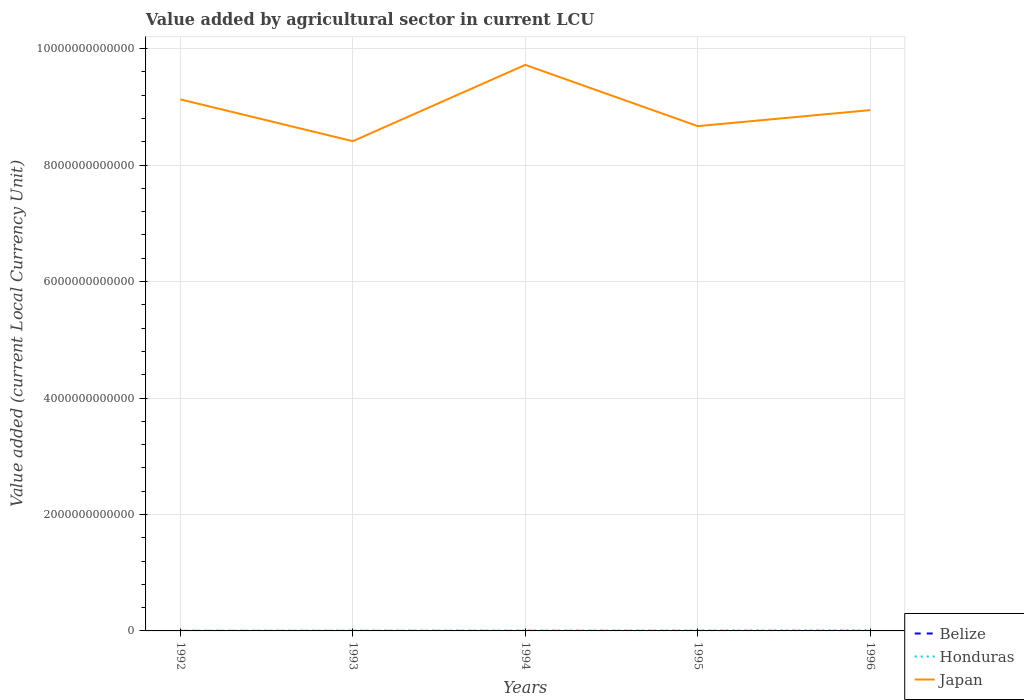Does the line corresponding to Honduras intersect with the line corresponding to Japan?
Make the answer very short. No. Is the number of lines equal to the number of legend labels?
Offer a very short reply. Yes. Across all years, what is the maximum value added by agricultural sector in Japan?
Your answer should be compact. 8.41e+12. In which year was the value added by agricultural sector in Japan maximum?
Offer a very short reply. 1993. What is the total value added by agricultural sector in Honduras in the graph?
Make the answer very short. -5.17e+09. What is the difference between the highest and the second highest value added by agricultural sector in Belize?
Ensure brevity in your answer.  3.73e+07. What is the difference between the highest and the lowest value added by agricultural sector in Belize?
Make the answer very short. 2. Is the value added by agricultural sector in Honduras strictly greater than the value added by agricultural sector in Belize over the years?
Your response must be concise. No. How many lines are there?
Give a very brief answer. 3. How many years are there in the graph?
Provide a short and direct response. 5. What is the difference between two consecutive major ticks on the Y-axis?
Your response must be concise. 2.00e+12. Where does the legend appear in the graph?
Keep it short and to the point. Bottom right. How are the legend labels stacked?
Your answer should be compact. Vertical. What is the title of the graph?
Keep it short and to the point. Value added by agricultural sector in current LCU. Does "Solomon Islands" appear as one of the legend labels in the graph?
Offer a terse response. No. What is the label or title of the X-axis?
Make the answer very short. Years. What is the label or title of the Y-axis?
Your response must be concise. Value added (current Local Currency Unit). What is the Value added (current Local Currency Unit) of Belize in 1992?
Your answer should be compact. 1.65e+08. What is the Value added (current Local Currency Unit) in Honduras in 1992?
Offer a terse response. 3.29e+09. What is the Value added (current Local Currency Unit) in Japan in 1992?
Your answer should be compact. 9.13e+12. What is the Value added (current Local Currency Unit) of Belize in 1993?
Make the answer very short. 1.69e+08. What is the Value added (current Local Currency Unit) in Honduras in 1993?
Your answer should be very brief. 4.01e+09. What is the Value added (current Local Currency Unit) in Japan in 1993?
Ensure brevity in your answer.  8.41e+12. What is the Value added (current Local Currency Unit) in Belize in 1994?
Offer a very short reply. 1.75e+08. What is the Value added (current Local Currency Unit) in Honduras in 1994?
Your answer should be compact. 6.03e+09. What is the Value added (current Local Currency Unit) in Japan in 1994?
Provide a succinct answer. 9.72e+12. What is the Value added (current Local Currency Unit) in Belize in 1995?
Provide a short and direct response. 1.98e+08. What is the Value added (current Local Currency Unit) in Honduras in 1995?
Give a very brief answer. 7.03e+09. What is the Value added (current Local Currency Unit) of Japan in 1995?
Your answer should be compact. 8.67e+12. What is the Value added (current Local Currency Unit) in Belize in 1996?
Give a very brief answer. 2.03e+08. What is the Value added (current Local Currency Unit) in Honduras in 1996?
Offer a terse response. 9.19e+09. What is the Value added (current Local Currency Unit) in Japan in 1996?
Your answer should be very brief. 8.94e+12. Across all years, what is the maximum Value added (current Local Currency Unit) in Belize?
Keep it short and to the point. 2.03e+08. Across all years, what is the maximum Value added (current Local Currency Unit) in Honduras?
Ensure brevity in your answer.  9.19e+09. Across all years, what is the maximum Value added (current Local Currency Unit) in Japan?
Give a very brief answer. 9.72e+12. Across all years, what is the minimum Value added (current Local Currency Unit) of Belize?
Offer a very short reply. 1.65e+08. Across all years, what is the minimum Value added (current Local Currency Unit) in Honduras?
Make the answer very short. 3.29e+09. Across all years, what is the minimum Value added (current Local Currency Unit) of Japan?
Make the answer very short. 8.41e+12. What is the total Value added (current Local Currency Unit) of Belize in the graph?
Keep it short and to the point. 9.10e+08. What is the total Value added (current Local Currency Unit) in Honduras in the graph?
Make the answer very short. 2.95e+1. What is the total Value added (current Local Currency Unit) in Japan in the graph?
Offer a very short reply. 4.49e+13. What is the difference between the Value added (current Local Currency Unit) of Belize in 1992 and that in 1993?
Make the answer very short. -3.79e+06. What is the difference between the Value added (current Local Currency Unit) of Honduras in 1992 and that in 1993?
Your answer should be compact. -7.28e+08. What is the difference between the Value added (current Local Currency Unit) of Japan in 1992 and that in 1993?
Make the answer very short. 7.18e+11. What is the difference between the Value added (current Local Currency Unit) of Belize in 1992 and that in 1994?
Provide a succinct answer. -9.67e+06. What is the difference between the Value added (current Local Currency Unit) in Honduras in 1992 and that in 1994?
Your response must be concise. -2.74e+09. What is the difference between the Value added (current Local Currency Unit) in Japan in 1992 and that in 1994?
Give a very brief answer. -5.93e+11. What is the difference between the Value added (current Local Currency Unit) of Belize in 1992 and that in 1995?
Offer a very short reply. -3.22e+07. What is the difference between the Value added (current Local Currency Unit) of Honduras in 1992 and that in 1995?
Your answer should be very brief. -3.74e+09. What is the difference between the Value added (current Local Currency Unit) of Japan in 1992 and that in 1995?
Provide a succinct answer. 4.59e+11. What is the difference between the Value added (current Local Currency Unit) of Belize in 1992 and that in 1996?
Make the answer very short. -3.73e+07. What is the difference between the Value added (current Local Currency Unit) in Honduras in 1992 and that in 1996?
Provide a succinct answer. -5.90e+09. What is the difference between the Value added (current Local Currency Unit) of Japan in 1992 and that in 1996?
Offer a very short reply. 1.84e+11. What is the difference between the Value added (current Local Currency Unit) of Belize in 1993 and that in 1994?
Your response must be concise. -5.88e+06. What is the difference between the Value added (current Local Currency Unit) of Honduras in 1993 and that in 1994?
Keep it short and to the point. -2.02e+09. What is the difference between the Value added (current Local Currency Unit) of Japan in 1993 and that in 1994?
Your response must be concise. -1.31e+12. What is the difference between the Value added (current Local Currency Unit) of Belize in 1993 and that in 1995?
Make the answer very short. -2.84e+07. What is the difference between the Value added (current Local Currency Unit) in Honduras in 1993 and that in 1995?
Provide a succinct answer. -3.01e+09. What is the difference between the Value added (current Local Currency Unit) of Japan in 1993 and that in 1995?
Provide a succinct answer. -2.59e+11. What is the difference between the Value added (current Local Currency Unit) of Belize in 1993 and that in 1996?
Provide a succinct answer. -3.36e+07. What is the difference between the Value added (current Local Currency Unit) in Honduras in 1993 and that in 1996?
Your answer should be compact. -5.17e+09. What is the difference between the Value added (current Local Currency Unit) in Japan in 1993 and that in 1996?
Your answer should be very brief. -5.33e+11. What is the difference between the Value added (current Local Currency Unit) in Belize in 1994 and that in 1995?
Your answer should be very brief. -2.25e+07. What is the difference between the Value added (current Local Currency Unit) of Honduras in 1994 and that in 1995?
Keep it short and to the point. -9.96e+08. What is the difference between the Value added (current Local Currency Unit) in Japan in 1994 and that in 1995?
Ensure brevity in your answer.  1.05e+12. What is the difference between the Value added (current Local Currency Unit) in Belize in 1994 and that in 1996?
Offer a terse response. -2.77e+07. What is the difference between the Value added (current Local Currency Unit) of Honduras in 1994 and that in 1996?
Make the answer very short. -3.16e+09. What is the difference between the Value added (current Local Currency Unit) of Japan in 1994 and that in 1996?
Give a very brief answer. 7.77e+11. What is the difference between the Value added (current Local Currency Unit) in Belize in 1995 and that in 1996?
Give a very brief answer. -5.16e+06. What is the difference between the Value added (current Local Currency Unit) of Honduras in 1995 and that in 1996?
Your answer should be compact. -2.16e+09. What is the difference between the Value added (current Local Currency Unit) of Japan in 1995 and that in 1996?
Make the answer very short. -2.75e+11. What is the difference between the Value added (current Local Currency Unit) in Belize in 1992 and the Value added (current Local Currency Unit) in Honduras in 1993?
Keep it short and to the point. -3.85e+09. What is the difference between the Value added (current Local Currency Unit) in Belize in 1992 and the Value added (current Local Currency Unit) in Japan in 1993?
Offer a terse response. -8.41e+12. What is the difference between the Value added (current Local Currency Unit) in Honduras in 1992 and the Value added (current Local Currency Unit) in Japan in 1993?
Offer a very short reply. -8.41e+12. What is the difference between the Value added (current Local Currency Unit) of Belize in 1992 and the Value added (current Local Currency Unit) of Honduras in 1994?
Make the answer very short. -5.86e+09. What is the difference between the Value added (current Local Currency Unit) in Belize in 1992 and the Value added (current Local Currency Unit) in Japan in 1994?
Offer a very short reply. -9.72e+12. What is the difference between the Value added (current Local Currency Unit) of Honduras in 1992 and the Value added (current Local Currency Unit) of Japan in 1994?
Your answer should be compact. -9.72e+12. What is the difference between the Value added (current Local Currency Unit) of Belize in 1992 and the Value added (current Local Currency Unit) of Honduras in 1995?
Offer a terse response. -6.86e+09. What is the difference between the Value added (current Local Currency Unit) of Belize in 1992 and the Value added (current Local Currency Unit) of Japan in 1995?
Your answer should be compact. -8.67e+12. What is the difference between the Value added (current Local Currency Unit) of Honduras in 1992 and the Value added (current Local Currency Unit) of Japan in 1995?
Provide a succinct answer. -8.67e+12. What is the difference between the Value added (current Local Currency Unit) in Belize in 1992 and the Value added (current Local Currency Unit) in Honduras in 1996?
Make the answer very short. -9.02e+09. What is the difference between the Value added (current Local Currency Unit) of Belize in 1992 and the Value added (current Local Currency Unit) of Japan in 1996?
Keep it short and to the point. -8.94e+12. What is the difference between the Value added (current Local Currency Unit) in Honduras in 1992 and the Value added (current Local Currency Unit) in Japan in 1996?
Your answer should be very brief. -8.94e+12. What is the difference between the Value added (current Local Currency Unit) in Belize in 1993 and the Value added (current Local Currency Unit) in Honduras in 1994?
Give a very brief answer. -5.86e+09. What is the difference between the Value added (current Local Currency Unit) of Belize in 1993 and the Value added (current Local Currency Unit) of Japan in 1994?
Keep it short and to the point. -9.72e+12. What is the difference between the Value added (current Local Currency Unit) in Honduras in 1993 and the Value added (current Local Currency Unit) in Japan in 1994?
Offer a terse response. -9.72e+12. What is the difference between the Value added (current Local Currency Unit) of Belize in 1993 and the Value added (current Local Currency Unit) of Honduras in 1995?
Your response must be concise. -6.86e+09. What is the difference between the Value added (current Local Currency Unit) in Belize in 1993 and the Value added (current Local Currency Unit) in Japan in 1995?
Provide a short and direct response. -8.67e+12. What is the difference between the Value added (current Local Currency Unit) in Honduras in 1993 and the Value added (current Local Currency Unit) in Japan in 1995?
Provide a succinct answer. -8.67e+12. What is the difference between the Value added (current Local Currency Unit) of Belize in 1993 and the Value added (current Local Currency Unit) of Honduras in 1996?
Your answer should be very brief. -9.02e+09. What is the difference between the Value added (current Local Currency Unit) of Belize in 1993 and the Value added (current Local Currency Unit) of Japan in 1996?
Ensure brevity in your answer.  -8.94e+12. What is the difference between the Value added (current Local Currency Unit) in Honduras in 1993 and the Value added (current Local Currency Unit) in Japan in 1996?
Your response must be concise. -8.94e+12. What is the difference between the Value added (current Local Currency Unit) of Belize in 1994 and the Value added (current Local Currency Unit) of Honduras in 1995?
Offer a very short reply. -6.85e+09. What is the difference between the Value added (current Local Currency Unit) of Belize in 1994 and the Value added (current Local Currency Unit) of Japan in 1995?
Your answer should be compact. -8.67e+12. What is the difference between the Value added (current Local Currency Unit) of Honduras in 1994 and the Value added (current Local Currency Unit) of Japan in 1995?
Give a very brief answer. -8.66e+12. What is the difference between the Value added (current Local Currency Unit) of Belize in 1994 and the Value added (current Local Currency Unit) of Honduras in 1996?
Ensure brevity in your answer.  -9.01e+09. What is the difference between the Value added (current Local Currency Unit) of Belize in 1994 and the Value added (current Local Currency Unit) of Japan in 1996?
Offer a very short reply. -8.94e+12. What is the difference between the Value added (current Local Currency Unit) of Honduras in 1994 and the Value added (current Local Currency Unit) of Japan in 1996?
Offer a very short reply. -8.94e+12. What is the difference between the Value added (current Local Currency Unit) of Belize in 1995 and the Value added (current Local Currency Unit) of Honduras in 1996?
Give a very brief answer. -8.99e+09. What is the difference between the Value added (current Local Currency Unit) of Belize in 1995 and the Value added (current Local Currency Unit) of Japan in 1996?
Keep it short and to the point. -8.94e+12. What is the difference between the Value added (current Local Currency Unit) of Honduras in 1995 and the Value added (current Local Currency Unit) of Japan in 1996?
Ensure brevity in your answer.  -8.94e+12. What is the average Value added (current Local Currency Unit) in Belize per year?
Your response must be concise. 1.82e+08. What is the average Value added (current Local Currency Unit) in Honduras per year?
Ensure brevity in your answer.  5.91e+09. What is the average Value added (current Local Currency Unit) of Japan per year?
Provide a short and direct response. 8.98e+12. In the year 1992, what is the difference between the Value added (current Local Currency Unit) of Belize and Value added (current Local Currency Unit) of Honduras?
Offer a terse response. -3.12e+09. In the year 1992, what is the difference between the Value added (current Local Currency Unit) in Belize and Value added (current Local Currency Unit) in Japan?
Your answer should be very brief. -9.13e+12. In the year 1992, what is the difference between the Value added (current Local Currency Unit) in Honduras and Value added (current Local Currency Unit) in Japan?
Ensure brevity in your answer.  -9.13e+12. In the year 1993, what is the difference between the Value added (current Local Currency Unit) in Belize and Value added (current Local Currency Unit) in Honduras?
Your answer should be compact. -3.84e+09. In the year 1993, what is the difference between the Value added (current Local Currency Unit) in Belize and Value added (current Local Currency Unit) in Japan?
Ensure brevity in your answer.  -8.41e+12. In the year 1993, what is the difference between the Value added (current Local Currency Unit) in Honduras and Value added (current Local Currency Unit) in Japan?
Your response must be concise. -8.41e+12. In the year 1994, what is the difference between the Value added (current Local Currency Unit) in Belize and Value added (current Local Currency Unit) in Honduras?
Make the answer very short. -5.85e+09. In the year 1994, what is the difference between the Value added (current Local Currency Unit) of Belize and Value added (current Local Currency Unit) of Japan?
Offer a very short reply. -9.72e+12. In the year 1994, what is the difference between the Value added (current Local Currency Unit) of Honduras and Value added (current Local Currency Unit) of Japan?
Your answer should be compact. -9.72e+12. In the year 1995, what is the difference between the Value added (current Local Currency Unit) of Belize and Value added (current Local Currency Unit) of Honduras?
Your response must be concise. -6.83e+09. In the year 1995, what is the difference between the Value added (current Local Currency Unit) in Belize and Value added (current Local Currency Unit) in Japan?
Provide a short and direct response. -8.67e+12. In the year 1995, what is the difference between the Value added (current Local Currency Unit) in Honduras and Value added (current Local Currency Unit) in Japan?
Make the answer very short. -8.66e+12. In the year 1996, what is the difference between the Value added (current Local Currency Unit) of Belize and Value added (current Local Currency Unit) of Honduras?
Provide a succinct answer. -8.99e+09. In the year 1996, what is the difference between the Value added (current Local Currency Unit) in Belize and Value added (current Local Currency Unit) in Japan?
Offer a terse response. -8.94e+12. In the year 1996, what is the difference between the Value added (current Local Currency Unit) in Honduras and Value added (current Local Currency Unit) in Japan?
Keep it short and to the point. -8.94e+12. What is the ratio of the Value added (current Local Currency Unit) of Belize in 1992 to that in 1993?
Your answer should be compact. 0.98. What is the ratio of the Value added (current Local Currency Unit) of Honduras in 1992 to that in 1993?
Provide a short and direct response. 0.82. What is the ratio of the Value added (current Local Currency Unit) in Japan in 1992 to that in 1993?
Give a very brief answer. 1.09. What is the ratio of the Value added (current Local Currency Unit) of Belize in 1992 to that in 1994?
Your response must be concise. 0.94. What is the ratio of the Value added (current Local Currency Unit) of Honduras in 1992 to that in 1994?
Give a very brief answer. 0.54. What is the ratio of the Value added (current Local Currency Unit) in Japan in 1992 to that in 1994?
Your answer should be very brief. 0.94. What is the ratio of the Value added (current Local Currency Unit) of Belize in 1992 to that in 1995?
Offer a terse response. 0.84. What is the ratio of the Value added (current Local Currency Unit) in Honduras in 1992 to that in 1995?
Provide a short and direct response. 0.47. What is the ratio of the Value added (current Local Currency Unit) in Japan in 1992 to that in 1995?
Your response must be concise. 1.05. What is the ratio of the Value added (current Local Currency Unit) of Belize in 1992 to that in 1996?
Your answer should be compact. 0.82. What is the ratio of the Value added (current Local Currency Unit) in Honduras in 1992 to that in 1996?
Provide a short and direct response. 0.36. What is the ratio of the Value added (current Local Currency Unit) in Japan in 1992 to that in 1996?
Provide a succinct answer. 1.02. What is the ratio of the Value added (current Local Currency Unit) of Belize in 1993 to that in 1994?
Ensure brevity in your answer.  0.97. What is the ratio of the Value added (current Local Currency Unit) in Honduras in 1993 to that in 1994?
Ensure brevity in your answer.  0.67. What is the ratio of the Value added (current Local Currency Unit) in Japan in 1993 to that in 1994?
Your response must be concise. 0.87. What is the ratio of the Value added (current Local Currency Unit) in Belize in 1993 to that in 1995?
Your answer should be very brief. 0.86. What is the ratio of the Value added (current Local Currency Unit) in Honduras in 1993 to that in 1995?
Your answer should be very brief. 0.57. What is the ratio of the Value added (current Local Currency Unit) in Japan in 1993 to that in 1995?
Your response must be concise. 0.97. What is the ratio of the Value added (current Local Currency Unit) of Belize in 1993 to that in 1996?
Your answer should be compact. 0.83. What is the ratio of the Value added (current Local Currency Unit) of Honduras in 1993 to that in 1996?
Make the answer very short. 0.44. What is the ratio of the Value added (current Local Currency Unit) of Japan in 1993 to that in 1996?
Provide a short and direct response. 0.94. What is the ratio of the Value added (current Local Currency Unit) in Belize in 1994 to that in 1995?
Your answer should be compact. 0.89. What is the ratio of the Value added (current Local Currency Unit) in Honduras in 1994 to that in 1995?
Make the answer very short. 0.86. What is the ratio of the Value added (current Local Currency Unit) in Japan in 1994 to that in 1995?
Provide a succinct answer. 1.12. What is the ratio of the Value added (current Local Currency Unit) of Belize in 1994 to that in 1996?
Ensure brevity in your answer.  0.86. What is the ratio of the Value added (current Local Currency Unit) of Honduras in 1994 to that in 1996?
Provide a short and direct response. 0.66. What is the ratio of the Value added (current Local Currency Unit) in Japan in 1994 to that in 1996?
Give a very brief answer. 1.09. What is the ratio of the Value added (current Local Currency Unit) in Belize in 1995 to that in 1996?
Offer a very short reply. 0.97. What is the ratio of the Value added (current Local Currency Unit) in Honduras in 1995 to that in 1996?
Provide a short and direct response. 0.76. What is the ratio of the Value added (current Local Currency Unit) of Japan in 1995 to that in 1996?
Provide a short and direct response. 0.97. What is the difference between the highest and the second highest Value added (current Local Currency Unit) of Belize?
Provide a short and direct response. 5.16e+06. What is the difference between the highest and the second highest Value added (current Local Currency Unit) in Honduras?
Provide a succinct answer. 2.16e+09. What is the difference between the highest and the second highest Value added (current Local Currency Unit) of Japan?
Your answer should be very brief. 5.93e+11. What is the difference between the highest and the lowest Value added (current Local Currency Unit) in Belize?
Your answer should be very brief. 3.73e+07. What is the difference between the highest and the lowest Value added (current Local Currency Unit) in Honduras?
Ensure brevity in your answer.  5.90e+09. What is the difference between the highest and the lowest Value added (current Local Currency Unit) in Japan?
Your response must be concise. 1.31e+12. 